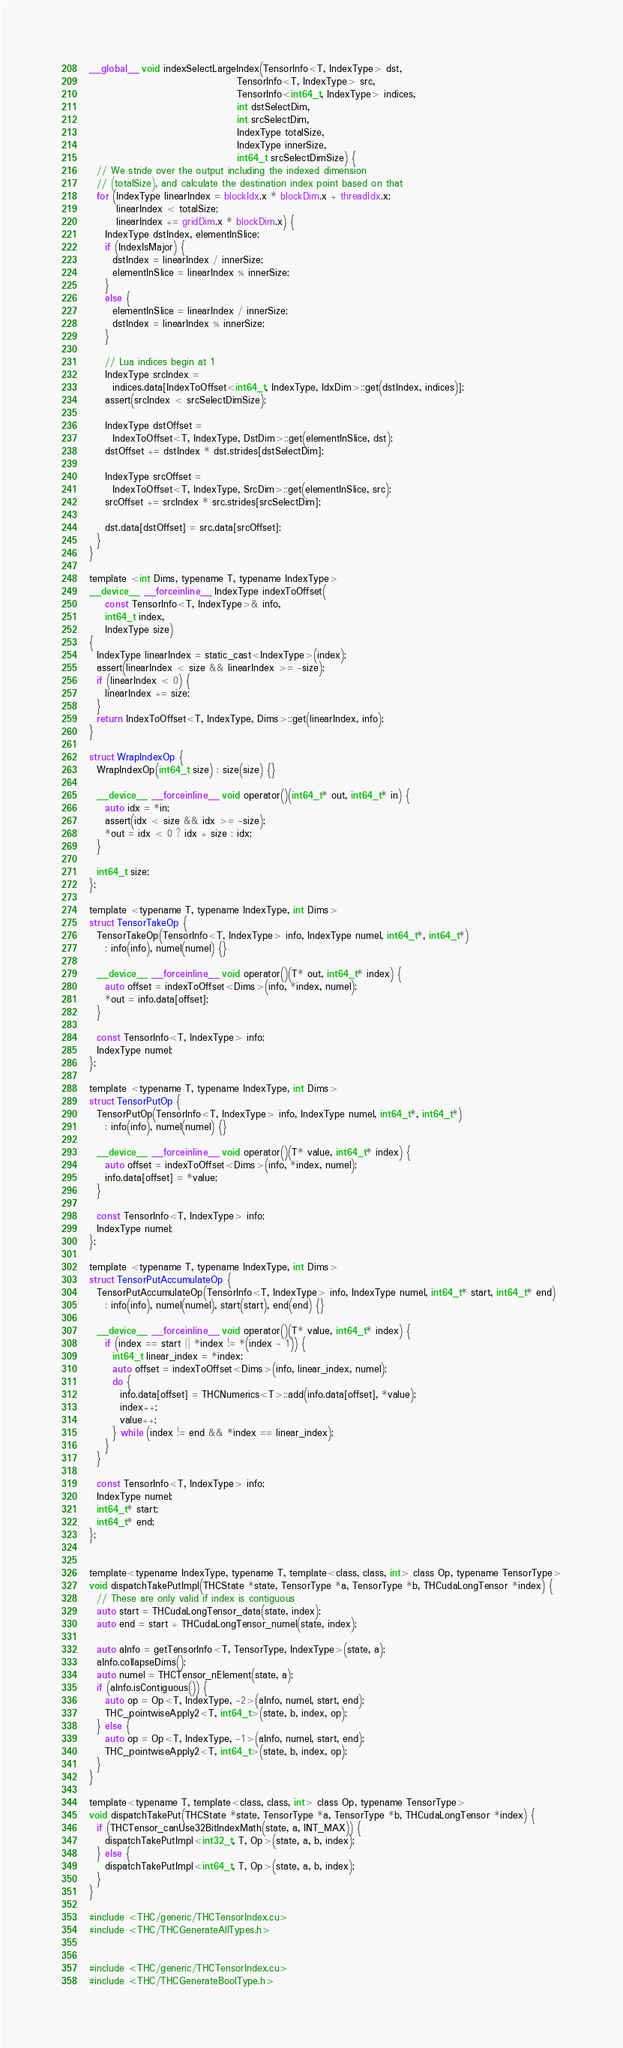<code> <loc_0><loc_0><loc_500><loc_500><_Cuda_>__global__ void indexSelectLargeIndex(TensorInfo<T, IndexType> dst,
                                      TensorInfo<T, IndexType> src,
                                      TensorInfo<int64_t, IndexType> indices,
                                      int dstSelectDim,
                                      int srcSelectDim,
                                      IndexType totalSize,
                                      IndexType innerSize,
                                      int64_t srcSelectDimSize) {
  // We stride over the output including the indexed dimension
  // (totalSize), and calculate the destination index point based on that
  for (IndexType linearIndex = blockIdx.x * blockDim.x + threadIdx.x;
       linearIndex < totalSize;
       linearIndex += gridDim.x * blockDim.x) {
    IndexType dstIndex, elementInSlice;
    if (IndexIsMajor) {
      dstIndex = linearIndex / innerSize;
      elementInSlice = linearIndex % innerSize;
    }
    else {
      elementInSlice = linearIndex / innerSize;
      dstIndex = linearIndex % innerSize;
    }

    // Lua indices begin at 1
    IndexType srcIndex =
      indices.data[IndexToOffset<int64_t, IndexType, IdxDim>::get(dstIndex, indices)];
    assert(srcIndex < srcSelectDimSize);

    IndexType dstOffset =
      IndexToOffset<T, IndexType, DstDim>::get(elementInSlice, dst);
    dstOffset += dstIndex * dst.strides[dstSelectDim];

    IndexType srcOffset =
      IndexToOffset<T, IndexType, SrcDim>::get(elementInSlice, src);
    srcOffset += srcIndex * src.strides[srcSelectDim];

    dst.data[dstOffset] = src.data[srcOffset];
  }
}

template <int Dims, typename T, typename IndexType>
__device__ __forceinline__ IndexType indexToOffset(
    const TensorInfo<T, IndexType>& info,
    int64_t index,
    IndexType size)
{
  IndexType linearIndex = static_cast<IndexType>(index);
  assert(linearIndex < size && linearIndex >= -size);
  if (linearIndex < 0) {
    linearIndex += size;
  }
  return IndexToOffset<T, IndexType, Dims>::get(linearIndex, info);
}

struct WrapIndexOp {
  WrapIndexOp(int64_t size) : size(size) {}

  __device__ __forceinline__ void operator()(int64_t* out, int64_t* in) {
    auto idx = *in;
    assert(idx < size && idx >= -size);
    *out = idx < 0 ? idx + size : idx;
  }

  int64_t size;
};

template <typename T, typename IndexType, int Dims>
struct TensorTakeOp {
  TensorTakeOp(TensorInfo<T, IndexType> info, IndexType numel, int64_t*, int64_t*)
    : info(info), numel(numel) {}

  __device__ __forceinline__ void operator()(T* out, int64_t* index) {
    auto offset = indexToOffset<Dims>(info, *index, numel);
    *out = info.data[offset];
  }

  const TensorInfo<T, IndexType> info;
  IndexType numel;
};

template <typename T, typename IndexType, int Dims>
struct TensorPutOp {
  TensorPutOp(TensorInfo<T, IndexType> info, IndexType numel, int64_t*, int64_t*)
    : info(info), numel(numel) {}

  __device__ __forceinline__ void operator()(T* value, int64_t* index) {
    auto offset = indexToOffset<Dims>(info, *index, numel);
    info.data[offset] = *value;
  }

  const TensorInfo<T, IndexType> info;
  IndexType numel;
};

template <typename T, typename IndexType, int Dims>
struct TensorPutAccumulateOp {
  TensorPutAccumulateOp(TensorInfo<T, IndexType> info, IndexType numel, int64_t* start, int64_t* end)
    : info(info), numel(numel), start(start), end(end) {}

  __device__ __forceinline__ void operator()(T* value, int64_t* index) {
    if (index == start || *index != *(index - 1)) {
      int64_t linear_index = *index;
      auto offset = indexToOffset<Dims>(info, linear_index, numel);
      do {
        info.data[offset] = THCNumerics<T>::add(info.data[offset], *value);
        index++;
        value++;
      } while (index != end && *index == linear_index);
    }
  }

  const TensorInfo<T, IndexType> info;
  IndexType numel;
  int64_t* start;
  int64_t* end;
};


template<typename IndexType, typename T, template<class, class, int> class Op, typename TensorType>
void dispatchTakePutImpl(THCState *state, TensorType *a, TensorType *b, THCudaLongTensor *index) {
  // These are only valid if index is contiguous
  auto start = THCudaLongTensor_data(state, index);
  auto end = start + THCudaLongTensor_numel(state, index);

  auto aInfo = getTensorInfo<T, TensorType, IndexType>(state, a);
  aInfo.collapseDims();
  auto numel = THCTensor_nElement(state, a);
  if (aInfo.isContiguous()) {
    auto op = Op<T, IndexType, -2>(aInfo, numel, start, end);
    THC_pointwiseApply2<T, int64_t>(state, b, index, op);
  } else {
    auto op = Op<T, IndexType, -1>(aInfo, numel, start, end);
    THC_pointwiseApply2<T, int64_t>(state, b, index, op);
  }
}

template<typename T, template<class, class, int> class Op, typename TensorType>
void dispatchTakePut(THCState *state, TensorType *a, TensorType *b, THCudaLongTensor *index) {
  if (THCTensor_canUse32BitIndexMath(state, a, INT_MAX)) {
    dispatchTakePutImpl<int32_t, T, Op>(state, a, b, index);
  } else {
    dispatchTakePutImpl<int64_t, T, Op>(state, a, b, index);
  }
}

#include <THC/generic/THCTensorIndex.cu>
#include <THC/THCGenerateAllTypes.h>


#include <THC/generic/THCTensorIndex.cu>
#include <THC/THCGenerateBoolType.h>
</code> 